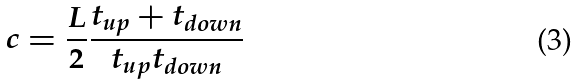Convert formula to latex. <formula><loc_0><loc_0><loc_500><loc_500>c = \frac { L } { 2 } \frac { t _ { u p } + t _ { d o w n } } { t _ { u p } t _ { d o w n } }</formula> 